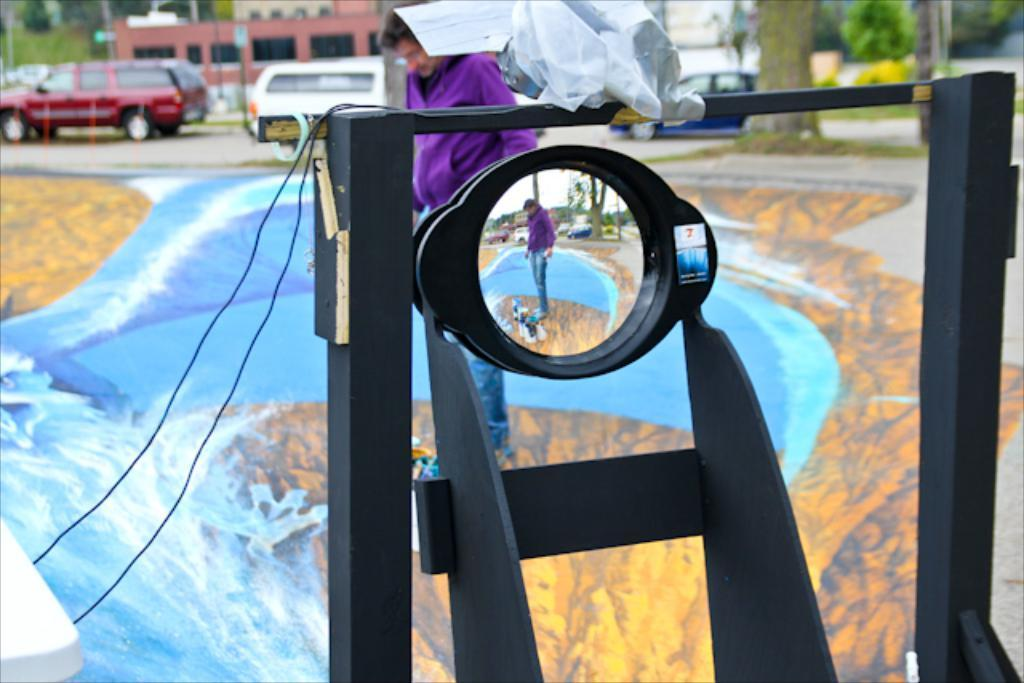What is the main subject in the center of the image? There is a person standing in the center of the image. What can be seen in the background of the image? There is a group of cars on the road, buildings with windows, trees, poles, and the bark of a tree in the background. What type of coal is being used for the activity in the image? There is no coal or activity involving coal present in the image. Can you spot a tiger in the image? There is no tiger present in the image. 